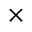Convert formula to latex. <formula><loc_0><loc_0><loc_500><loc_500>\times</formula> 